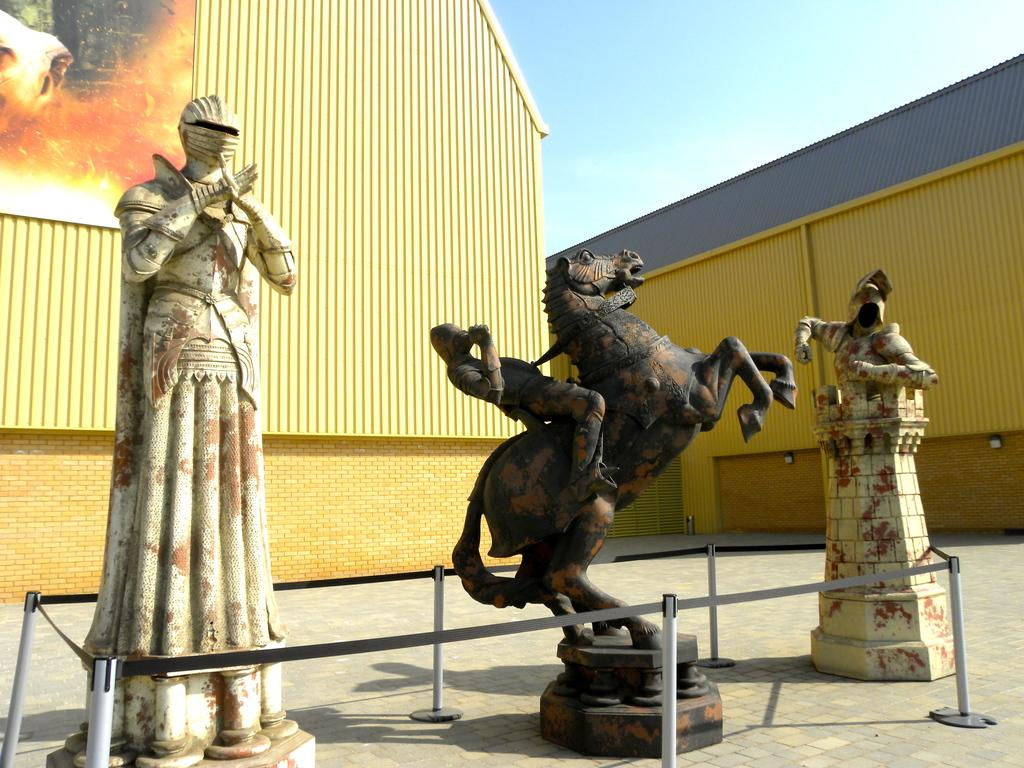What type of sculptures can be seen in the image? There are sculptures of people and a horse in the image. What type of structures are present in the image? There are houses in the image. What is attached to the wall in the image? There is a poster in the image. What type of path is visible in the image? There is a footpath in the image. What is visible in the sky in the image? The sky is visible in the image. What type of vertical structures are present in the image? There are poles in the image. What type of religious symbol is present in the image? There is a cross, not tape, in the image. How many pigs are present in the image? There are no pigs present in the image. What type of comfort can be seen in the image? The image does not depict any type of comfort. Is there any evidence of war in the image? There is no indication of war in the image. 